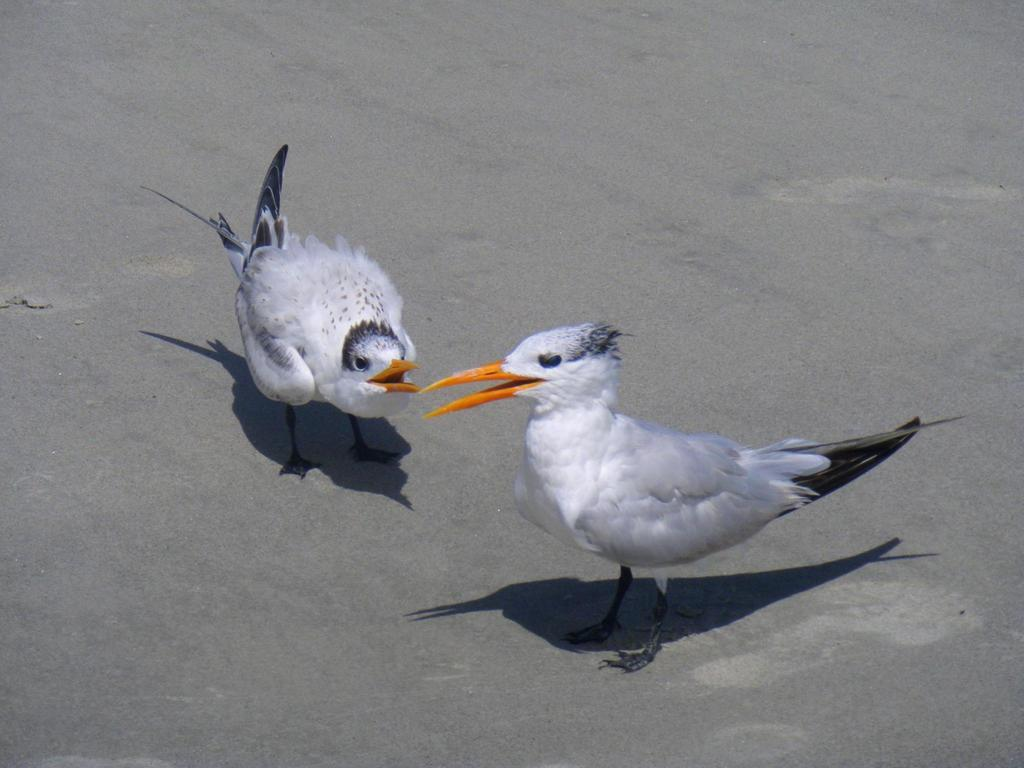How many birds are in the image? There are two birds in the image. What is the surface that the birds are standing on? The birds are standing on an ash-colored surface. What colors can be seen on the birds? The birds have white, black, and orange coloring. What type of beef is being prepared on the rake in the image? There is no beef or rake present in the image; it features two birds standing on an ash-colored surface. Is the person driving a car in the image? There is no person or car present in the image; it features two birds standing on an ash-colored surface. 